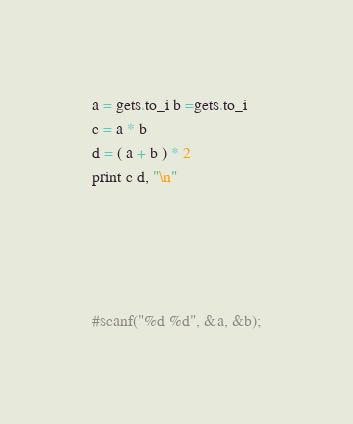<code> <loc_0><loc_0><loc_500><loc_500><_Ruby_>a = gets.to_i b =gets.to_i
c = a * b
d = ( a + b ) * 2
print c d, "\n"





#scanf("%d %d", &a, &b);</code> 